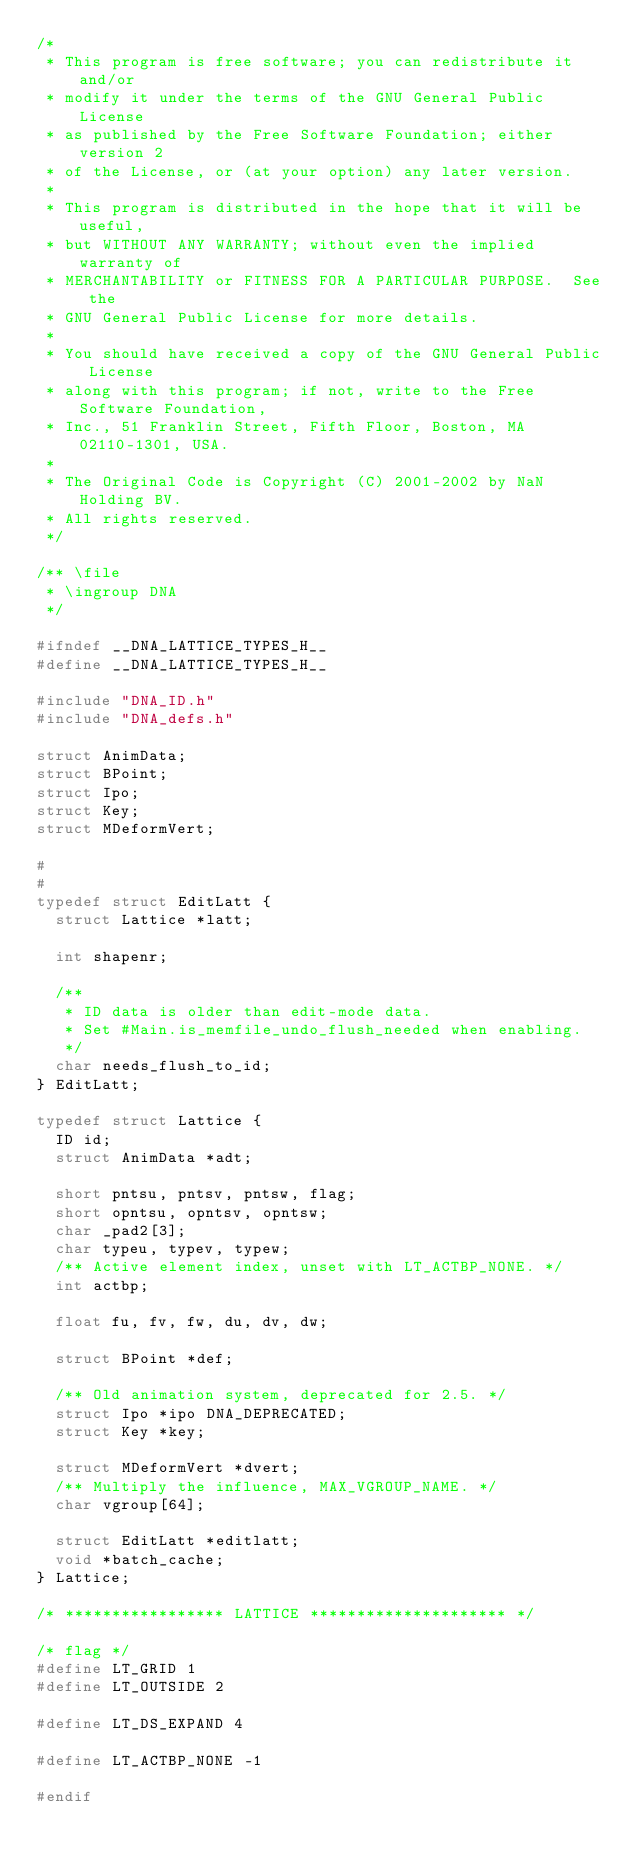Convert code to text. <code><loc_0><loc_0><loc_500><loc_500><_C_>/*
 * This program is free software; you can redistribute it and/or
 * modify it under the terms of the GNU General Public License
 * as published by the Free Software Foundation; either version 2
 * of the License, or (at your option) any later version.
 *
 * This program is distributed in the hope that it will be useful,
 * but WITHOUT ANY WARRANTY; without even the implied warranty of
 * MERCHANTABILITY or FITNESS FOR A PARTICULAR PURPOSE.  See the
 * GNU General Public License for more details.
 *
 * You should have received a copy of the GNU General Public License
 * along with this program; if not, write to the Free Software Foundation,
 * Inc., 51 Franklin Street, Fifth Floor, Boston, MA 02110-1301, USA.
 *
 * The Original Code is Copyright (C) 2001-2002 by NaN Holding BV.
 * All rights reserved.
 */

/** \file
 * \ingroup DNA
 */

#ifndef __DNA_LATTICE_TYPES_H__
#define __DNA_LATTICE_TYPES_H__

#include "DNA_ID.h"
#include "DNA_defs.h"

struct AnimData;
struct BPoint;
struct Ipo;
struct Key;
struct MDeformVert;

#
#
typedef struct EditLatt {
  struct Lattice *latt;

  int shapenr;

  /**
   * ID data is older than edit-mode data.
   * Set #Main.is_memfile_undo_flush_needed when enabling.
   */
  char needs_flush_to_id;
} EditLatt;

typedef struct Lattice {
  ID id;
  struct AnimData *adt;

  short pntsu, pntsv, pntsw, flag;
  short opntsu, opntsv, opntsw;
  char _pad2[3];
  char typeu, typev, typew;
  /** Active element index, unset with LT_ACTBP_NONE. */
  int actbp;

  float fu, fv, fw, du, dv, dw;

  struct BPoint *def;

  /** Old animation system, deprecated for 2.5. */
  struct Ipo *ipo DNA_DEPRECATED;
  struct Key *key;

  struct MDeformVert *dvert;
  /** Multiply the influence, MAX_VGROUP_NAME. */
  char vgroup[64];

  struct EditLatt *editlatt;
  void *batch_cache;
} Lattice;

/* ***************** LATTICE ********************* */

/* flag */
#define LT_GRID 1
#define LT_OUTSIDE 2

#define LT_DS_EXPAND 4

#define LT_ACTBP_NONE -1

#endif
</code> 